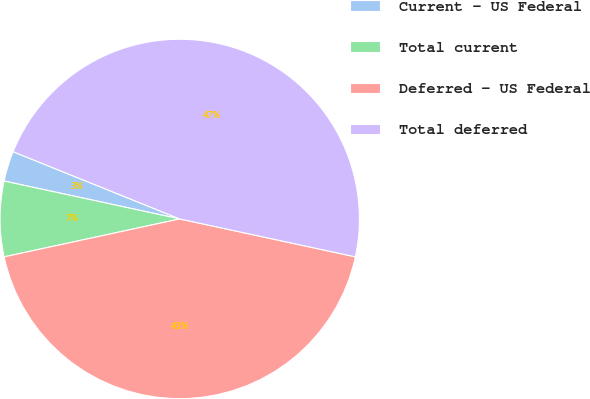<chart> <loc_0><loc_0><loc_500><loc_500><pie_chart><fcel>Current - US Federal<fcel>Total current<fcel>Deferred - US Federal<fcel>Total deferred<nl><fcel>2.72%<fcel>6.77%<fcel>43.23%<fcel>47.28%<nl></chart> 